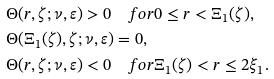Convert formula to latex. <formula><loc_0><loc_0><loc_500><loc_500>& \Theta ( r , \zeta ; \nu , \varepsilon ) > 0 \quad f o r 0 \leq r < \Xi _ { 1 } ( \zeta ) , \\ & \Theta ( \Xi _ { 1 } ( \zeta ) , \zeta ; \nu , \varepsilon ) = 0 , \\ & \Theta ( r , \zeta ; \nu , \varepsilon ) < 0 \quad f o r \Xi _ { 1 } ( \zeta ) < r \leq 2 \xi _ { 1 } .</formula> 